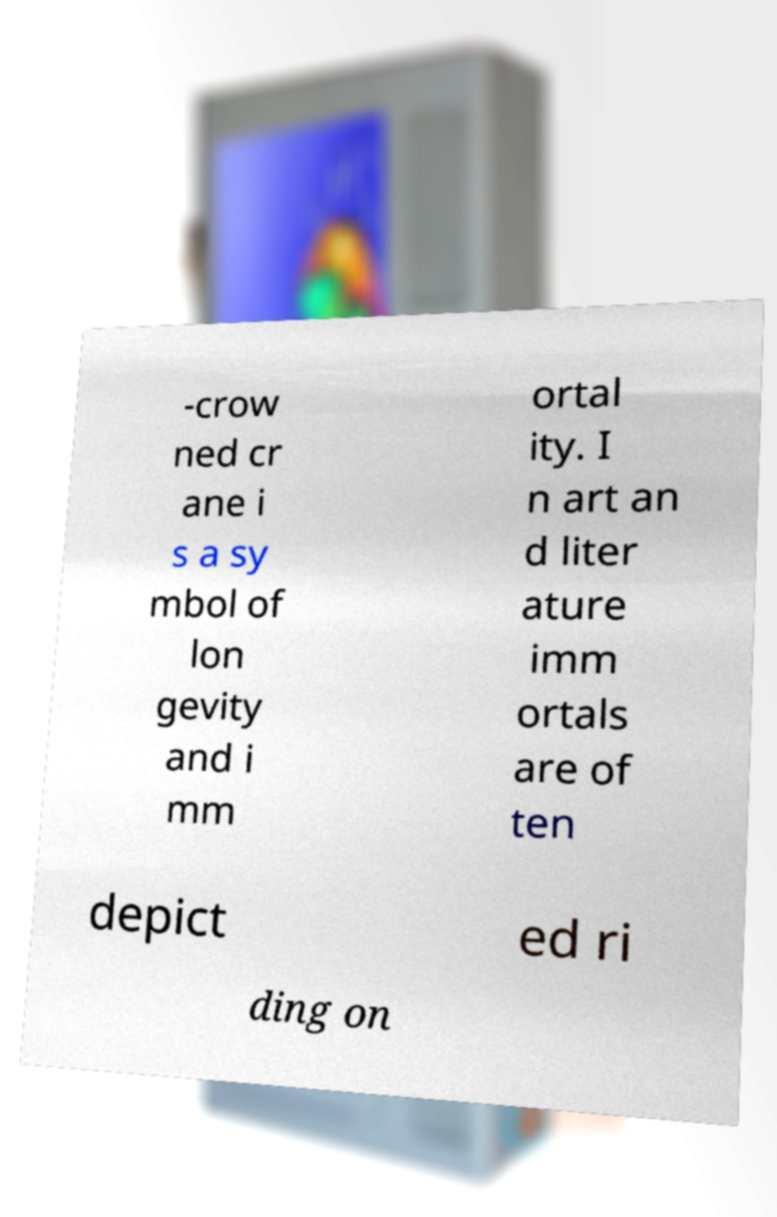Please identify and transcribe the text found in this image. -crow ned cr ane i s a sy mbol of lon gevity and i mm ortal ity. I n art an d liter ature imm ortals are of ten depict ed ri ding on 